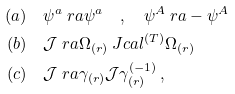Convert formula to latex. <formula><loc_0><loc_0><loc_500><loc_500>( a ) & \quad \psi ^ { a } \ r a \psi ^ { a } \quad , \quad \psi ^ { A } \ r a - \psi ^ { A } \\ ( b ) & \quad \mathcal { J } \ r a \Omega _ { ( r ) } \ J c a l ^ { ( T ) } \Omega _ { ( r ) } \\ ( c ) & \quad \mathcal { J } \ r a \gamma _ { ( r ) } \mathcal { J } \gamma ^ { ( - 1 ) } _ { ( r ) } \, ,</formula> 